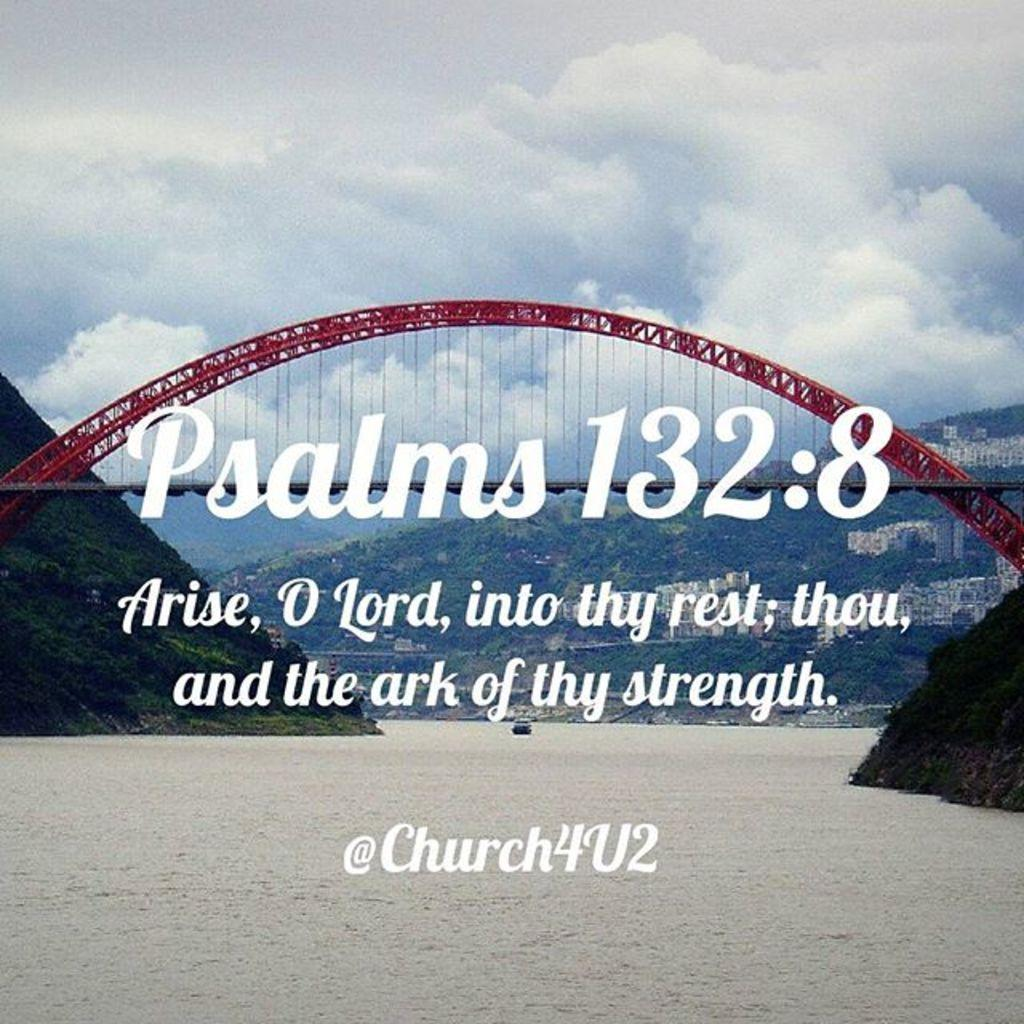<image>
Describe the image concisely. A picture of a bridge with the pharse Psalms 132:8 